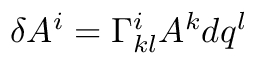<formula> <loc_0><loc_0><loc_500><loc_500>\delta A ^ { i } = \Gamma _ { k l } ^ { i } A ^ { k } d q ^ { l }</formula> 